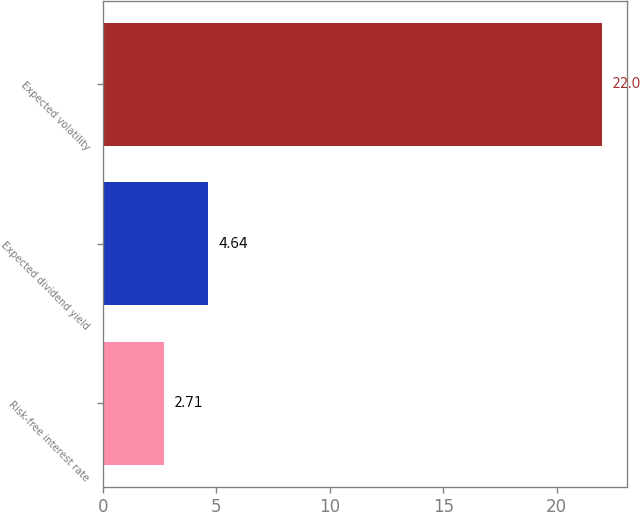Convert chart to OTSL. <chart><loc_0><loc_0><loc_500><loc_500><bar_chart><fcel>Risk-free interest rate<fcel>Expected dividend yield<fcel>Expected volatility<nl><fcel>2.71<fcel>4.64<fcel>22<nl></chart> 